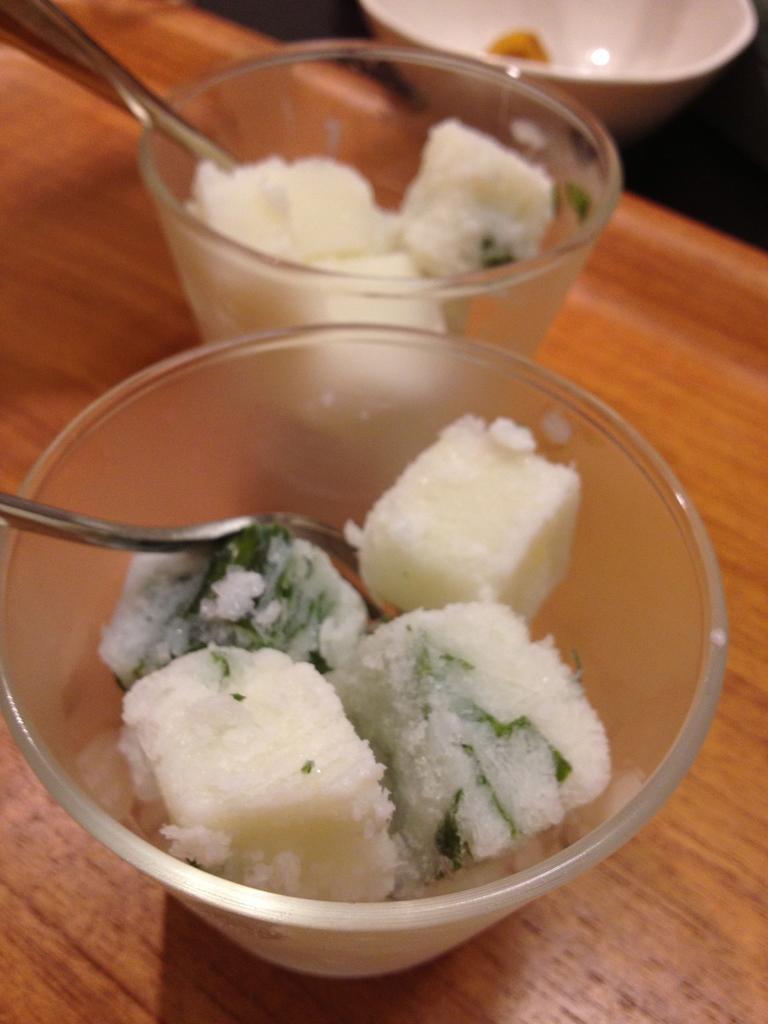Describe this image in one or two sentences. In this image there is a table and we can see bowls, spoons and some food placed on the table. 